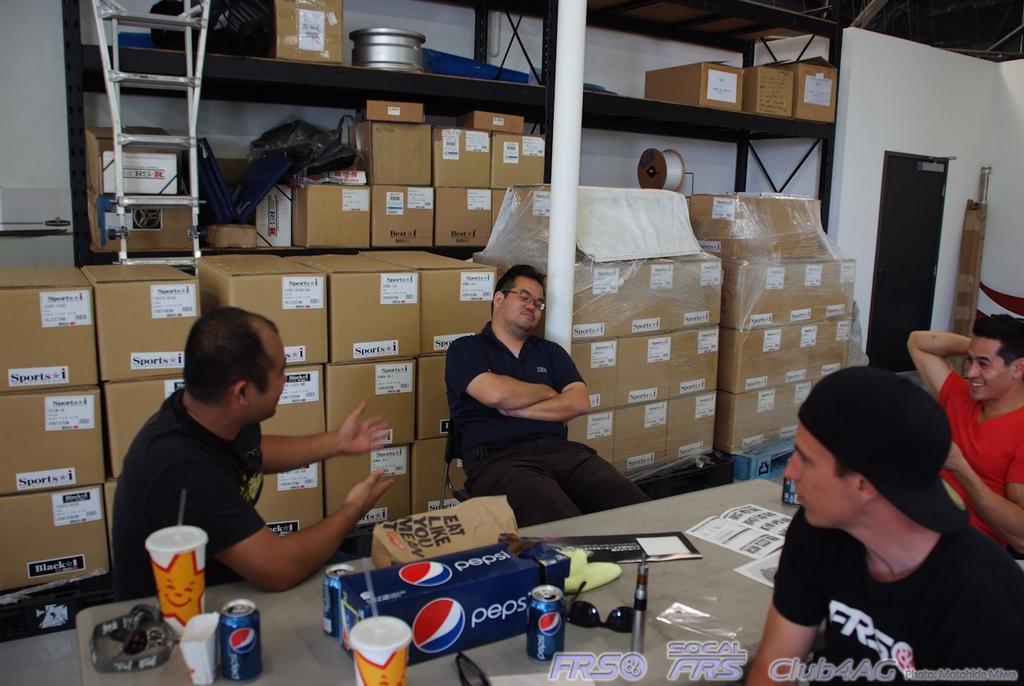Please provide a concise description of this image. In this picture we can see four persons sitting around the table. And on the table there is a tin,glass, box, papers, and goggles. And on the background there are many card boxes. And there is a rack. This is the wall and there is a door. 